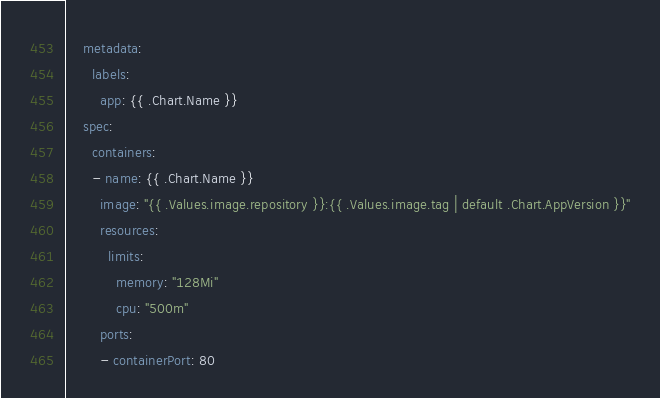Convert code to text. <code><loc_0><loc_0><loc_500><loc_500><_YAML_>    metadata:
      labels:
        app: {{ .Chart.Name }}
    spec:
      containers:
      - name: {{ .Chart.Name }}
        image: "{{ .Values.image.repository }}:{{ .Values.image.tag | default .Chart.AppVersion }}"
        resources:
          limits:
            memory: "128Mi"
            cpu: "500m"
        ports:
        - containerPort: 80
</code> 